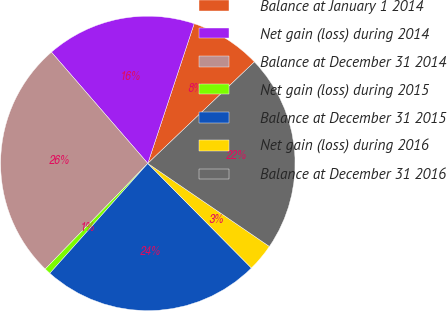Convert chart to OTSL. <chart><loc_0><loc_0><loc_500><loc_500><pie_chart><fcel>Balance at January 1 2014<fcel>Net gain (loss) during 2014<fcel>Balance at December 31 2014<fcel>Net gain (loss) during 2015<fcel>Balance at December 31 2015<fcel>Net gain (loss) during 2016<fcel>Balance at December 31 2016<nl><fcel>7.79%<fcel>16.46%<fcel>26.37%<fcel>0.68%<fcel>24.01%<fcel>3.04%<fcel>21.65%<nl></chart> 